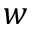<formula> <loc_0><loc_0><loc_500><loc_500>w</formula> 